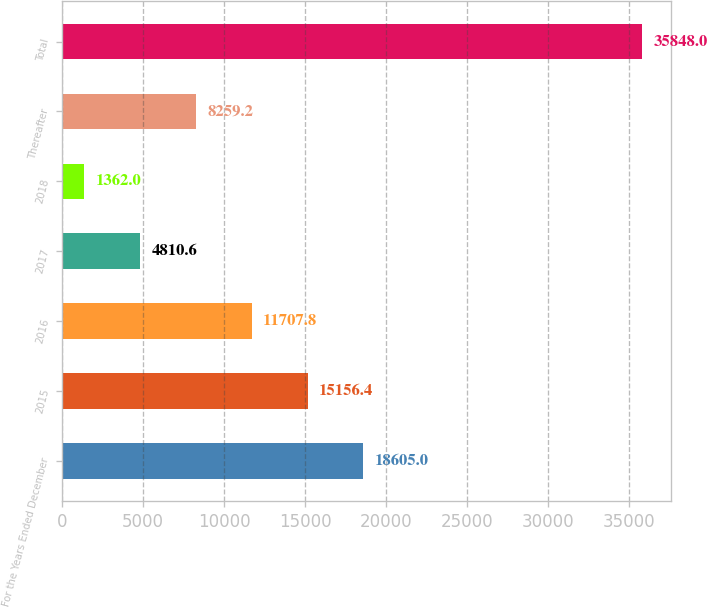Convert chart. <chart><loc_0><loc_0><loc_500><loc_500><bar_chart><fcel>For the Years Ended December<fcel>2015<fcel>2016<fcel>2017<fcel>2018<fcel>Thereafter<fcel>Total<nl><fcel>18605<fcel>15156.4<fcel>11707.8<fcel>4810.6<fcel>1362<fcel>8259.2<fcel>35848<nl></chart> 